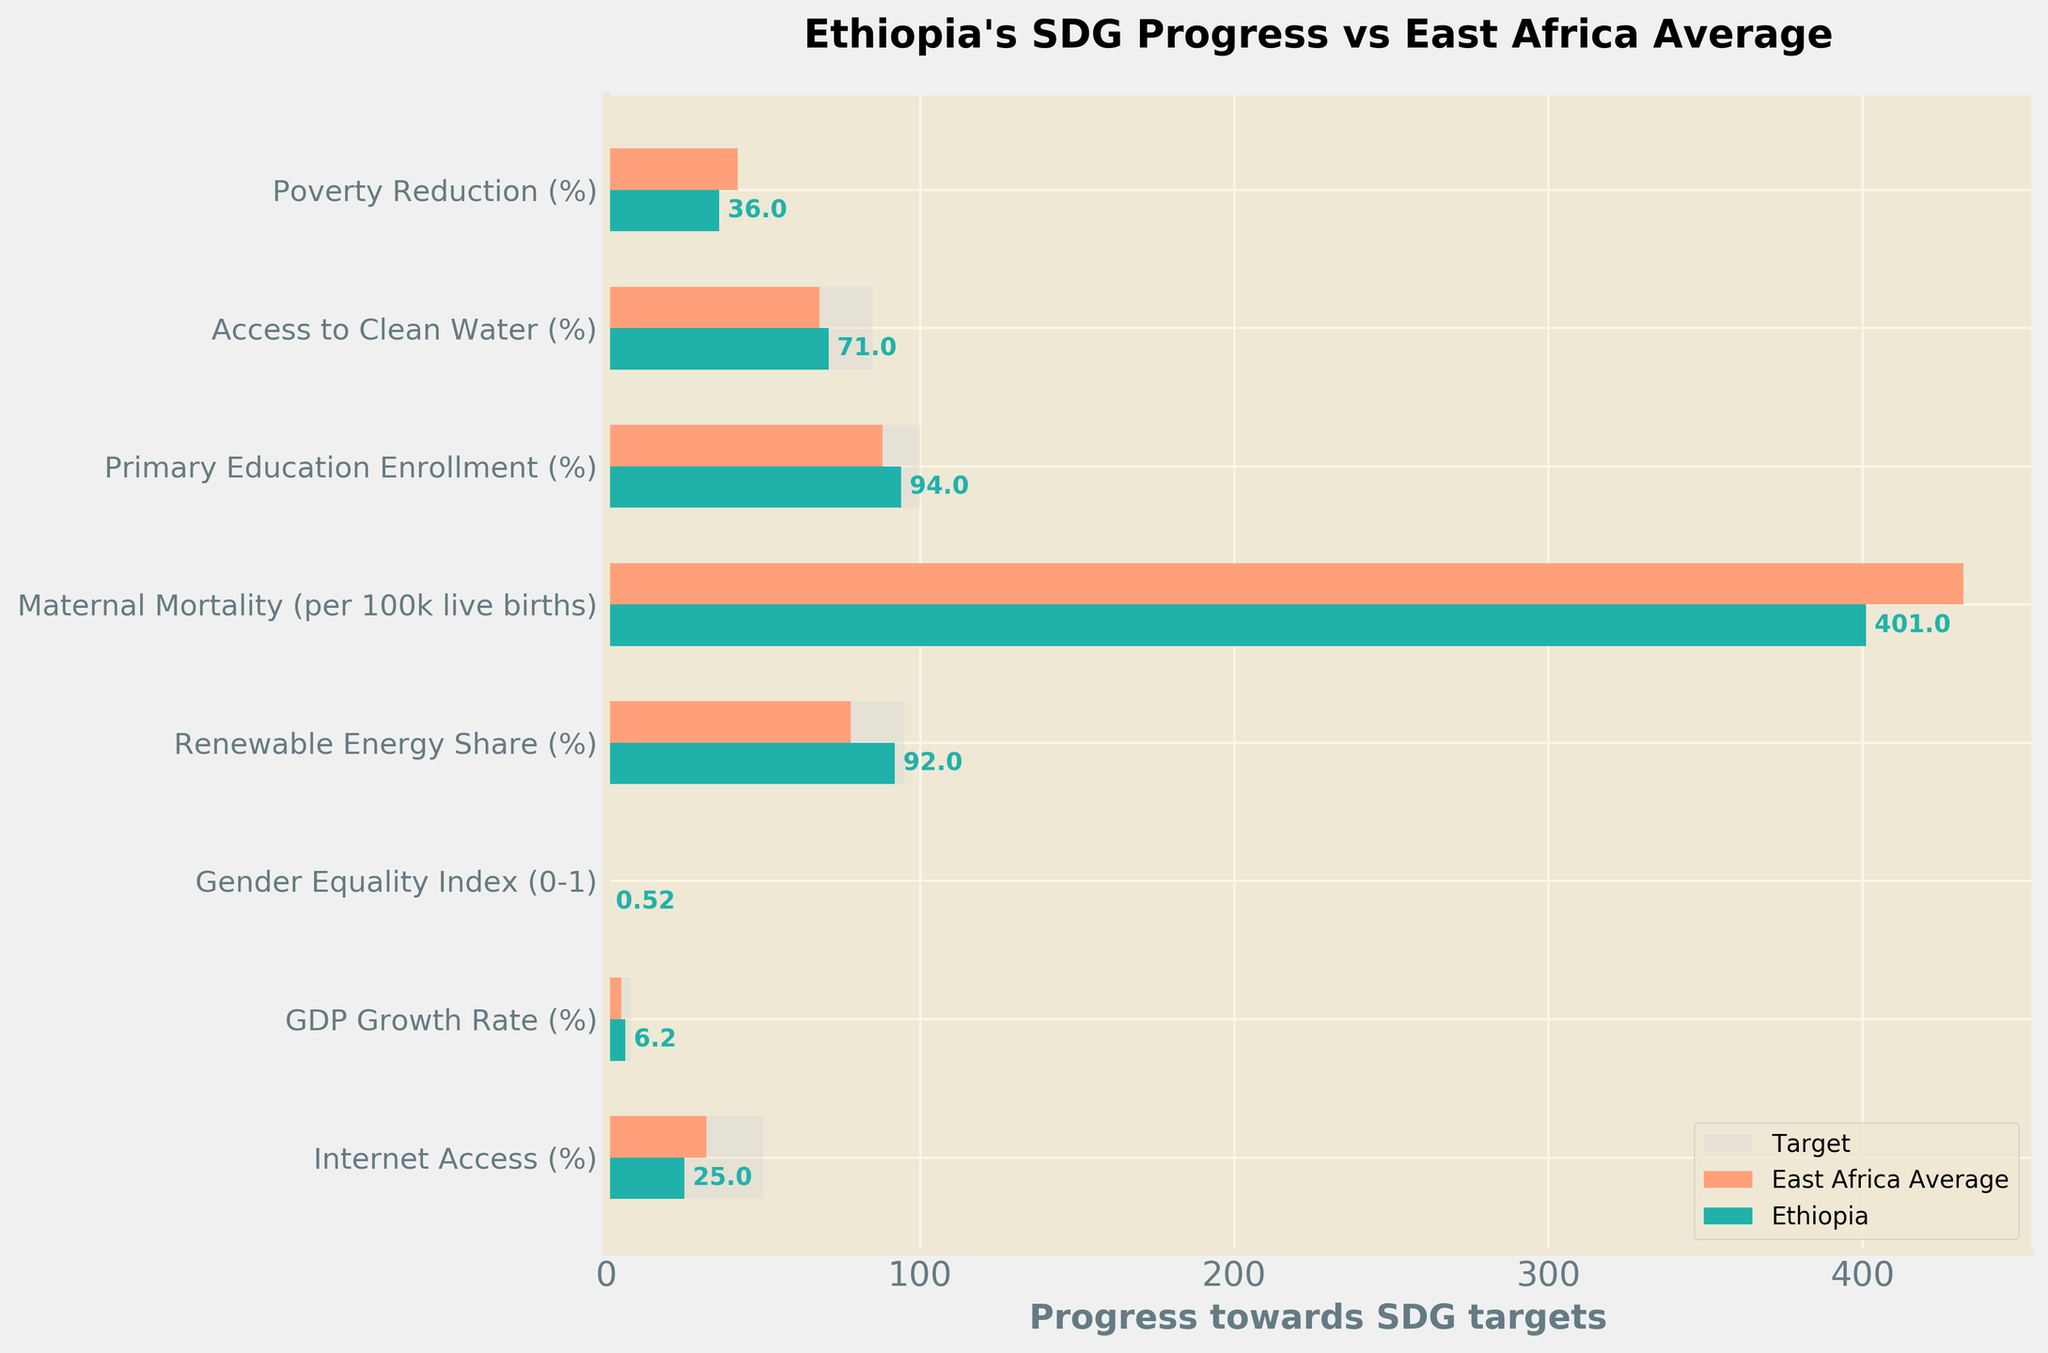What is the title of the figure? The title is located at the top of the figure and summarizes the purpose of the chart
Answer: Ethiopia's SDG Progress vs East Africa Average Which Sustainable Development Goal has the highest target value? By comparing the target values for each goal, the one with the highest number is identified
Answer: Primary Education Enrollment (%), with a target of 100% What is Ethiopia's achievement in Renewable Energy Share (%)? Locate the bar representing Renewable Energy Share (%) and observe the value marked for Ethiopia
Answer: 92% How does Ethiopia's Internet Access (%) compare to the East Africa average? Identify the bars representing Internet Access (%) for both Ethiopia and East Africa Average and compare their lengths/values
Answer: Ethiopia's Internet Access (%) is 25%, which is lower than the East Africa average of 32% Which SDG shows Ethiopia performing better than the East Africa average? Compare the values of Ethiopia to the East Africa average for each SDG and identify where Ethiopia's value is higher
Answer: Ethiopia performs better in Renewable Energy Share (%), Primary Education Enrollment (%), Maternal Mortality, and Access to Clean Water (%) What is the difference in Maternal Mortality (per 100k live births) between Ethiopia and the East Africa average? Subtract Ethiopia's value from the East Africa average value for Maternal Mortality
Answer: The difference is 432 - 401 = 31 (per 100,000 live births) How far is Ethiopia from achieving the target for Gender Equality Index (0-1)? Subtract Ethiopia's current value from the target value for Gender Equality Index
Answer: The difference is 0.7 - 0.52 = 0.18 What is the primary color used to highlight Ethiopia's progress in the chart? Identify the color used for Ethiopia's data bars
Answer: The primary color is a shade of green (#20B2AA) Which SDG shows the largest difference between Ethiopia and the East Africa average? Calculate the absolute differences between Ethiopia’s values and the East Africa averages for each SDG and identify the largest difference
Answer: Maternal Mortality (31 per 100,000 live births) Which Sustainable Development Goal (%) is closest to being met by Ethiopia according to the chart? Compare Ethiopia's values to the respective targets and identify which is closest to reaching its target
Answer: Primary Education Enrollment (%) is closest, with 94% against a target of 100% 